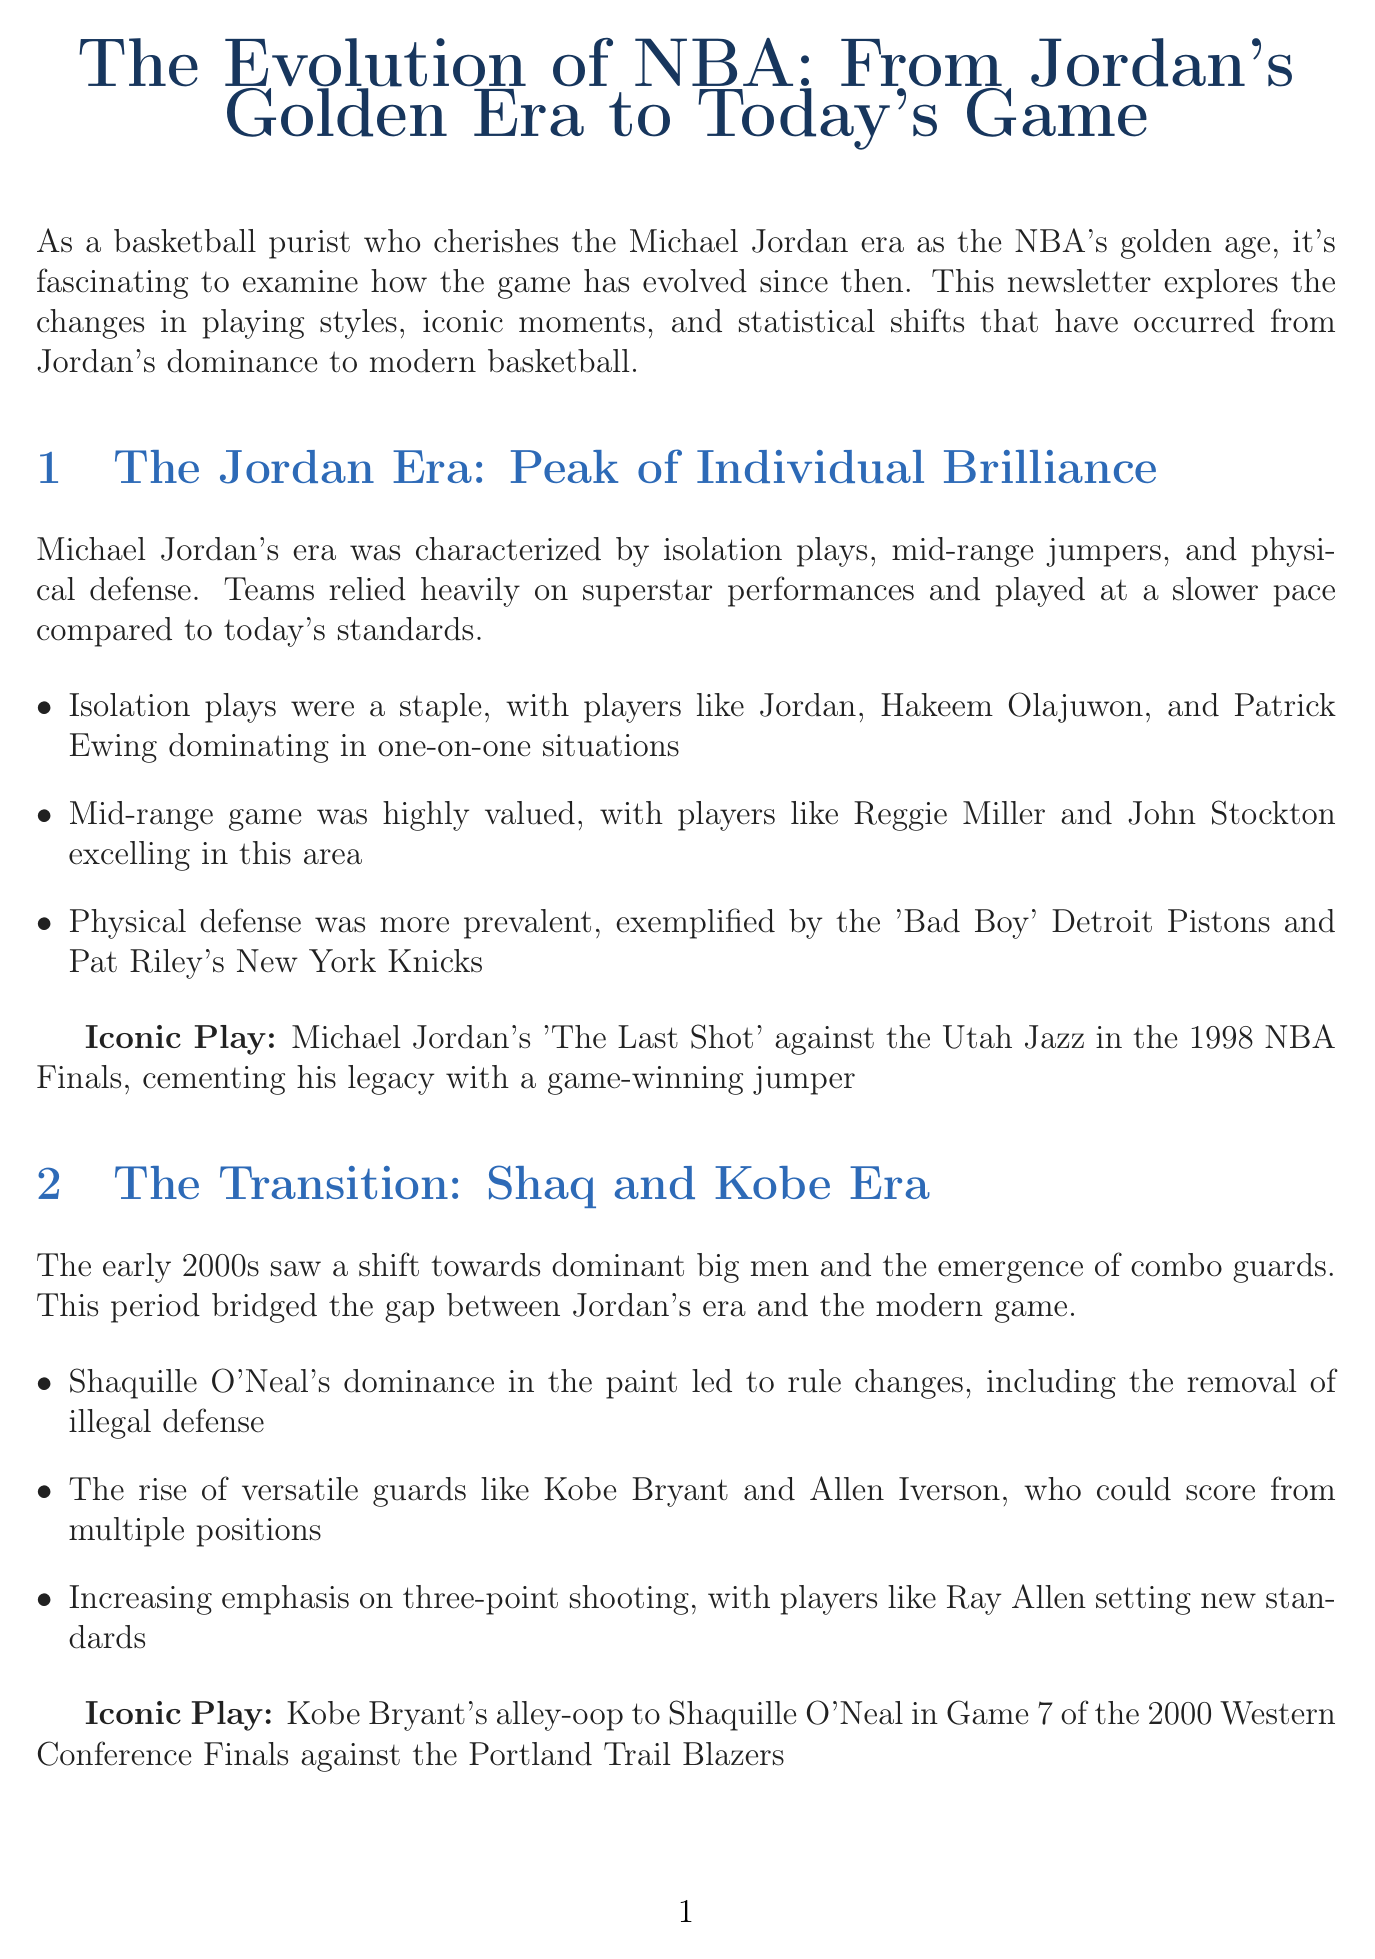What iconic play is linked to the Jordan era? The document lists iconic plays associated with each era, and for the Jordan era, it highlights "Michael Jordan's 'The Last Shot' against the Utah Jazz in the 1998 NBA Finals."
Answer: Michael Jordan's 'The Last Shot' What significant change happened in the early 2000s regarding defense rules? The document states that Shaquille O'Neal's dominance led to rule changes, specifically the "removal of illegal defense."
Answer: Removal of illegal defense What was the average number of three-point attempts per game in the 1990s? According to the statistical comparisons, the average number of three-point attempts per game in the 1990s is provided as 13.7.
Answer: 13.7 Which player is mentioned as a key figure in the transition era? The document mentions "Kobe Bryant" as a featured player in the transition from Jordan's era to modern basketball.
Answer: Kobe Bryant How has the average player height changed from the 1990s to the 2020s? The document indicates that the average player height in the 1990s was 6'7" and decreased to 6'6" in the 2020s, reflecting trends in player positions.
Answer: 6'6" What type of play has become more prominent in modern basketball? The newsletter emphasizes "three-point shooting" as a key feature in the modern basketball style, especially highlighted by teams like the Golden State Warriors.
Answer: Three-point shooting 